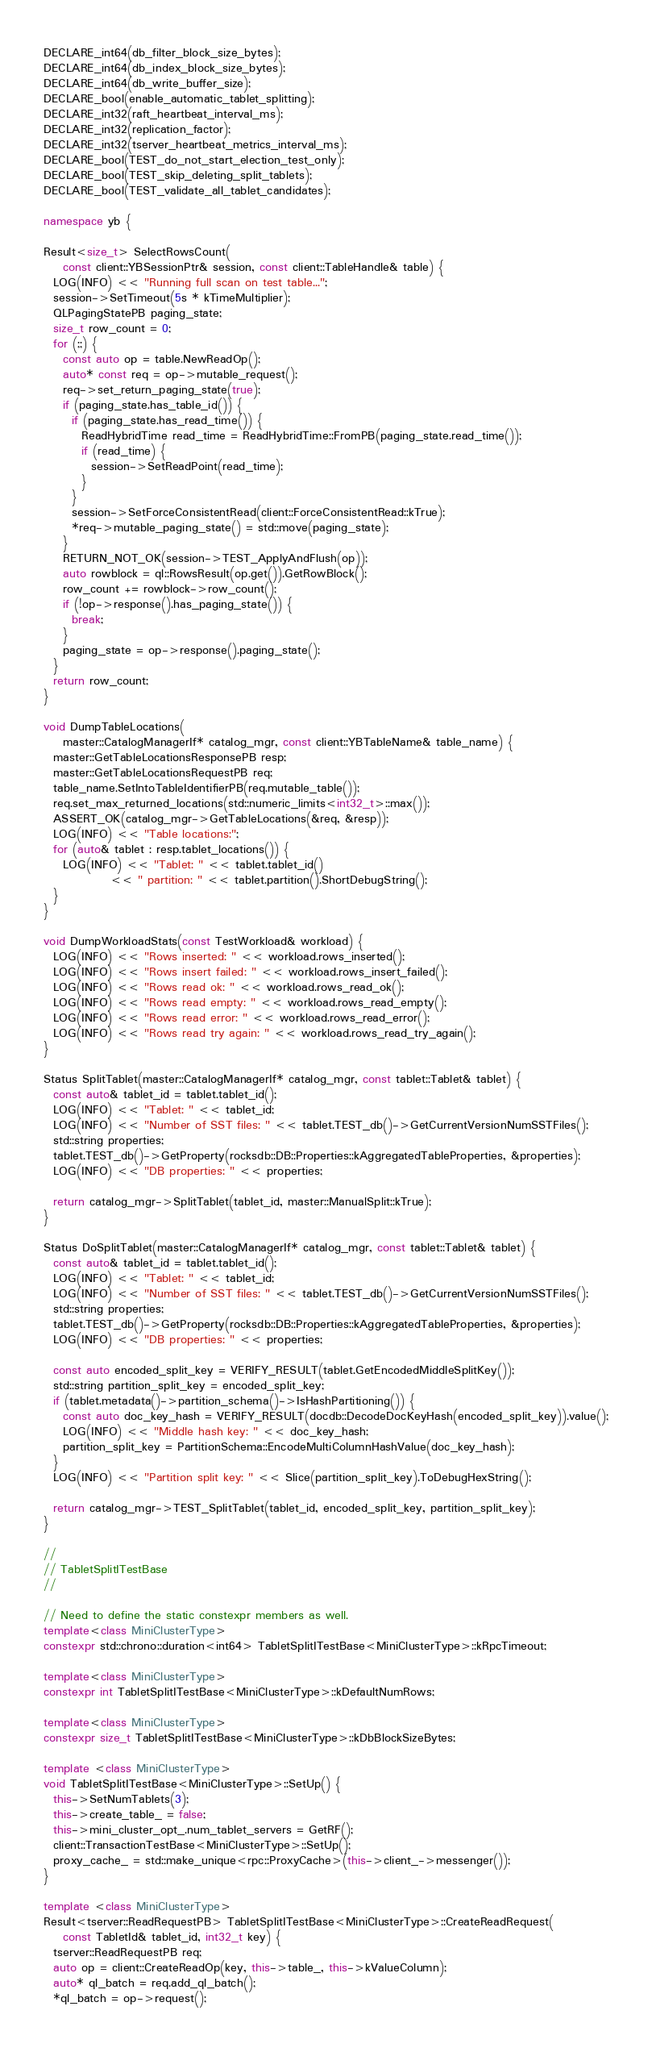<code> <loc_0><loc_0><loc_500><loc_500><_C++_>DECLARE_int64(db_filter_block_size_bytes);
DECLARE_int64(db_index_block_size_bytes);
DECLARE_int64(db_write_buffer_size);
DECLARE_bool(enable_automatic_tablet_splitting);
DECLARE_int32(raft_heartbeat_interval_ms);
DECLARE_int32(replication_factor);
DECLARE_int32(tserver_heartbeat_metrics_interval_ms);
DECLARE_bool(TEST_do_not_start_election_test_only);
DECLARE_bool(TEST_skip_deleting_split_tablets);
DECLARE_bool(TEST_validate_all_tablet_candidates);

namespace yb {

Result<size_t> SelectRowsCount(
    const client::YBSessionPtr& session, const client::TableHandle& table) {
  LOG(INFO) << "Running full scan on test table...";
  session->SetTimeout(5s * kTimeMultiplier);
  QLPagingStatePB paging_state;
  size_t row_count = 0;
  for (;;) {
    const auto op = table.NewReadOp();
    auto* const req = op->mutable_request();
    req->set_return_paging_state(true);
    if (paging_state.has_table_id()) {
      if (paging_state.has_read_time()) {
        ReadHybridTime read_time = ReadHybridTime::FromPB(paging_state.read_time());
        if (read_time) {
          session->SetReadPoint(read_time);
        }
      }
      session->SetForceConsistentRead(client::ForceConsistentRead::kTrue);
      *req->mutable_paging_state() = std::move(paging_state);
    }
    RETURN_NOT_OK(session->TEST_ApplyAndFlush(op));
    auto rowblock = ql::RowsResult(op.get()).GetRowBlock();
    row_count += rowblock->row_count();
    if (!op->response().has_paging_state()) {
      break;
    }
    paging_state = op->response().paging_state();
  }
  return row_count;
}

void DumpTableLocations(
    master::CatalogManagerIf* catalog_mgr, const client::YBTableName& table_name) {
  master::GetTableLocationsResponsePB resp;
  master::GetTableLocationsRequestPB req;
  table_name.SetIntoTableIdentifierPB(req.mutable_table());
  req.set_max_returned_locations(std::numeric_limits<int32_t>::max());
  ASSERT_OK(catalog_mgr->GetTableLocations(&req, &resp));
  LOG(INFO) << "Table locations:";
  for (auto& tablet : resp.tablet_locations()) {
    LOG(INFO) << "Tablet: " << tablet.tablet_id()
              << " partition: " << tablet.partition().ShortDebugString();
  }
}

void DumpWorkloadStats(const TestWorkload& workload) {
  LOG(INFO) << "Rows inserted: " << workload.rows_inserted();
  LOG(INFO) << "Rows insert failed: " << workload.rows_insert_failed();
  LOG(INFO) << "Rows read ok: " << workload.rows_read_ok();
  LOG(INFO) << "Rows read empty: " << workload.rows_read_empty();
  LOG(INFO) << "Rows read error: " << workload.rows_read_error();
  LOG(INFO) << "Rows read try again: " << workload.rows_read_try_again();
}

Status SplitTablet(master::CatalogManagerIf* catalog_mgr, const tablet::Tablet& tablet) {
  const auto& tablet_id = tablet.tablet_id();
  LOG(INFO) << "Tablet: " << tablet_id;
  LOG(INFO) << "Number of SST files: " << tablet.TEST_db()->GetCurrentVersionNumSSTFiles();
  std::string properties;
  tablet.TEST_db()->GetProperty(rocksdb::DB::Properties::kAggregatedTableProperties, &properties);
  LOG(INFO) << "DB properties: " << properties;

  return catalog_mgr->SplitTablet(tablet_id, master::ManualSplit::kTrue);
}

Status DoSplitTablet(master::CatalogManagerIf* catalog_mgr, const tablet::Tablet& tablet) {
  const auto& tablet_id = tablet.tablet_id();
  LOG(INFO) << "Tablet: " << tablet_id;
  LOG(INFO) << "Number of SST files: " << tablet.TEST_db()->GetCurrentVersionNumSSTFiles();
  std::string properties;
  tablet.TEST_db()->GetProperty(rocksdb::DB::Properties::kAggregatedTableProperties, &properties);
  LOG(INFO) << "DB properties: " << properties;

  const auto encoded_split_key = VERIFY_RESULT(tablet.GetEncodedMiddleSplitKey());
  std::string partition_split_key = encoded_split_key;
  if (tablet.metadata()->partition_schema()->IsHashPartitioning()) {
    const auto doc_key_hash = VERIFY_RESULT(docdb::DecodeDocKeyHash(encoded_split_key)).value();
    LOG(INFO) << "Middle hash key: " << doc_key_hash;
    partition_split_key = PartitionSchema::EncodeMultiColumnHashValue(doc_key_hash);
  }
  LOG(INFO) << "Partition split key: " << Slice(partition_split_key).ToDebugHexString();

  return catalog_mgr->TEST_SplitTablet(tablet_id, encoded_split_key, partition_split_key);
}

//
// TabletSplitITestBase
//

// Need to define the static constexpr members as well.
template<class MiniClusterType>
constexpr std::chrono::duration<int64> TabletSplitITestBase<MiniClusterType>::kRpcTimeout;

template<class MiniClusterType>
constexpr int TabletSplitITestBase<MiniClusterType>::kDefaultNumRows;

template<class MiniClusterType>
constexpr size_t TabletSplitITestBase<MiniClusterType>::kDbBlockSizeBytes;

template <class MiniClusterType>
void TabletSplitITestBase<MiniClusterType>::SetUp() {
  this->SetNumTablets(3);
  this->create_table_ = false;
  this->mini_cluster_opt_.num_tablet_servers = GetRF();
  client::TransactionTestBase<MiniClusterType>::SetUp();
  proxy_cache_ = std::make_unique<rpc::ProxyCache>(this->client_->messenger());
}

template <class MiniClusterType>
Result<tserver::ReadRequestPB> TabletSplitITestBase<MiniClusterType>::CreateReadRequest(
    const TabletId& tablet_id, int32_t key) {
  tserver::ReadRequestPB req;
  auto op = client::CreateReadOp(key, this->table_, this->kValueColumn);
  auto* ql_batch = req.add_ql_batch();
  *ql_batch = op->request();
</code> 